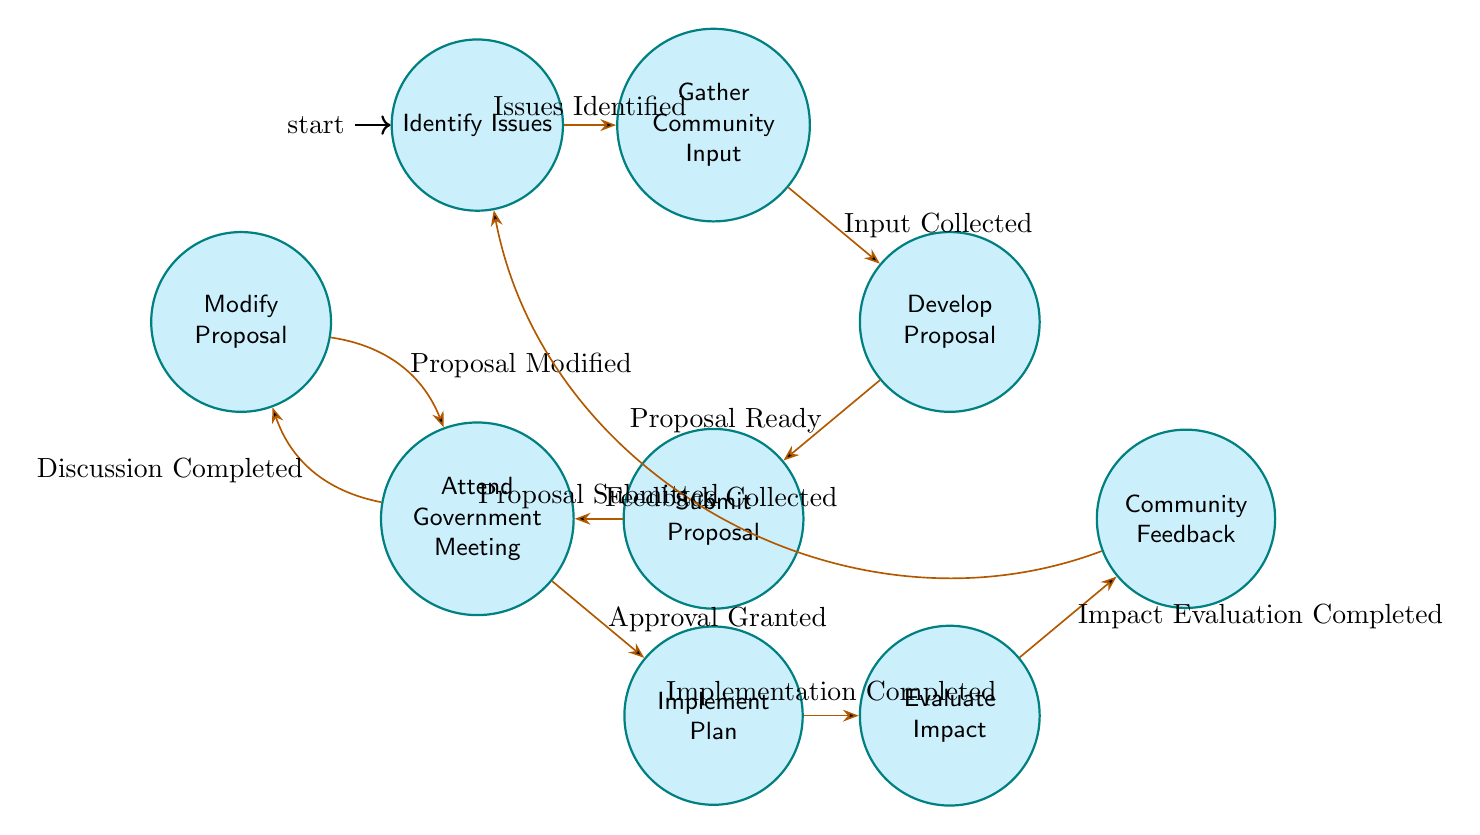What is the initial state in the diagram? The initial state in the diagram is "Identify Issues," which is marked as the starting point in the finite state machine.
Answer: Identify Issues How many states are present in the diagram? The diagram contains a total of 9 states, each representing a different stage in coordinating infrastructure improvements.
Answer: 9 What happens after "Gather Community Input"? After "Gather Community Input," the next state is "Develop Proposal," which indicates the process of creating a proposal based on the gathered input.
Answer: Develop Proposal What event leads to the transition from "Attend Government Meeting" to "Modify Proposal"? The event that leads to this transition is "Discussion Completed," indicating that feedback from the meeting requires changes to the proposal.
Answer: Discussion Completed What do you need to do before submitting the proposal to the local government? Before submitting, you must develop the proposal that details the necessary infrastructure improvements based on community input.
Answer: Develop Proposal Which state follows "Implement Plan"? The state that follows "Implement Plan" is "Evaluate Impact," reflecting the assessment of the improvements made after implementation.
Answer: Evaluate Impact What state is reached after gathering feedback from the community? After gathering feedback from the community, you return to the "Identify Issues" state to potentially start the process again.
Answer: Identify Issues How is the proposal modified based on local government feedback? The proposal is modified by transitioning to the "Modify Proposal" state after discussions with local officials, implying necessary adjustments based on their feedback.
Answer: Modify Proposal What event signifies that the implementation of the infrastructure improvements has been completed? The event that signifies completion of the implementation is "Implementation Completed," which indicates the work has been finished and the evaluation process can begin.
Answer: Implementation Completed 